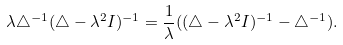Convert formula to latex. <formula><loc_0><loc_0><loc_500><loc_500>\lambda \triangle ^ { - 1 } ( \triangle - \lambda ^ { 2 } I ) ^ { - 1 } = \frac { 1 } { \lambda } ( ( \triangle - \lambda ^ { 2 } I ) ^ { - 1 } - \triangle ^ { - 1 } ) .</formula> 